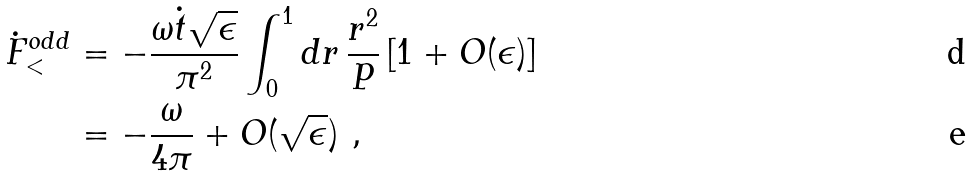<formula> <loc_0><loc_0><loc_500><loc_500>\dot { F } ^ { o d d } _ { < } & = - \frac { \omega \dot { t } \sqrt { \epsilon } } { \pi ^ { 2 } } \int _ { 0 } ^ { 1 } d r \, \frac { r ^ { 2 } } { P } \left [ 1 + O ( \epsilon ) \right ] \\ & = - \frac { \omega } { 4 \pi } + O ( \sqrt { \epsilon } ) \ ,</formula> 